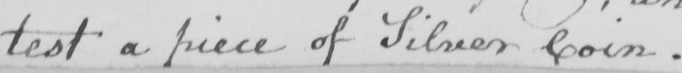Transcribe the text shown in this historical manuscript line. test a piece of Silver Coin . 